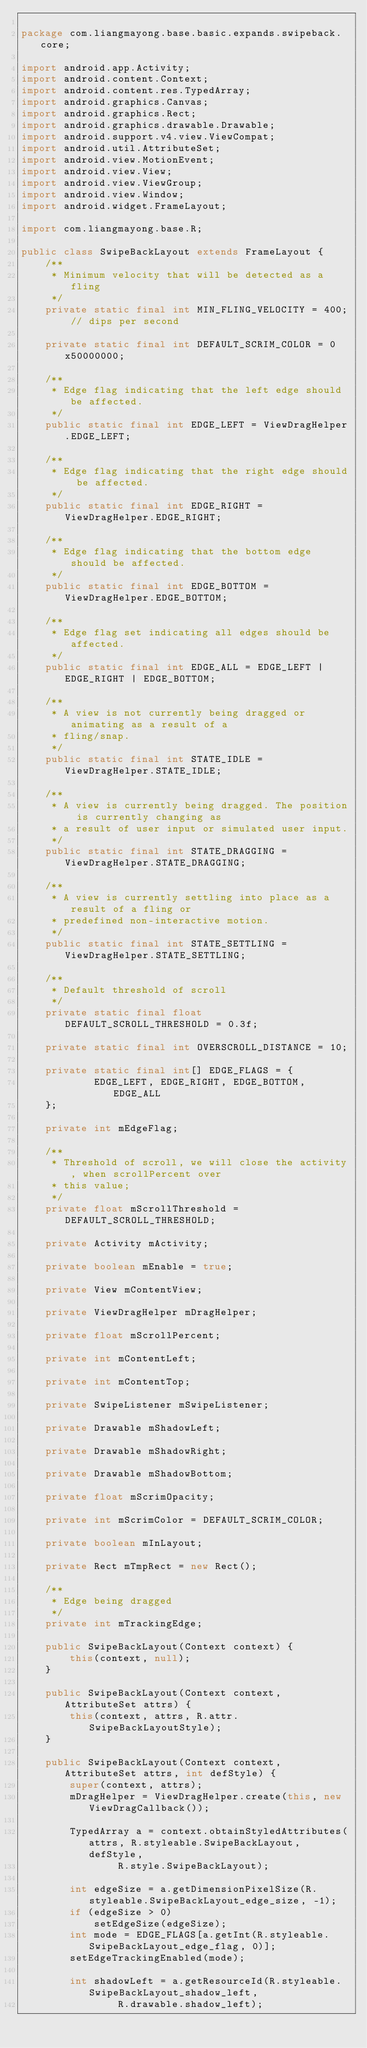<code> <loc_0><loc_0><loc_500><loc_500><_Java_>
package com.liangmayong.base.basic.expands.swipeback.core;

import android.app.Activity;
import android.content.Context;
import android.content.res.TypedArray;
import android.graphics.Canvas;
import android.graphics.Rect;
import android.graphics.drawable.Drawable;
import android.support.v4.view.ViewCompat;
import android.util.AttributeSet;
import android.view.MotionEvent;
import android.view.View;
import android.view.ViewGroup;
import android.view.Window;
import android.widget.FrameLayout;

import com.liangmayong.base.R;

public class SwipeBackLayout extends FrameLayout {
    /**
     * Minimum velocity that will be detected as a fling
     */
    private static final int MIN_FLING_VELOCITY = 400; // dips per second

    private static final int DEFAULT_SCRIM_COLOR = 0x50000000;

    /**
     * Edge flag indicating that the left edge should be affected.
     */
    public static final int EDGE_LEFT = ViewDragHelper.EDGE_LEFT;

    /**
     * Edge flag indicating that the right edge should be affected.
     */
    public static final int EDGE_RIGHT = ViewDragHelper.EDGE_RIGHT;

    /**
     * Edge flag indicating that the bottom edge should be affected.
     */
    public static final int EDGE_BOTTOM = ViewDragHelper.EDGE_BOTTOM;

    /**
     * Edge flag set indicating all edges should be affected.
     */
    public static final int EDGE_ALL = EDGE_LEFT | EDGE_RIGHT | EDGE_BOTTOM;

    /**
     * A view is not currently being dragged or animating as a result of a
     * fling/snap.
     */
    public static final int STATE_IDLE = ViewDragHelper.STATE_IDLE;

    /**
     * A view is currently being dragged. The position is currently changing as
     * a result of user input or simulated user input.
     */
    public static final int STATE_DRAGGING = ViewDragHelper.STATE_DRAGGING;

    /**
     * A view is currently settling into place as a result of a fling or
     * predefined non-interactive motion.
     */
    public static final int STATE_SETTLING = ViewDragHelper.STATE_SETTLING;

    /**
     * Default threshold of scroll
     */
    private static final float DEFAULT_SCROLL_THRESHOLD = 0.3f;

    private static final int OVERSCROLL_DISTANCE = 10;

    private static final int[] EDGE_FLAGS = {
            EDGE_LEFT, EDGE_RIGHT, EDGE_BOTTOM, EDGE_ALL
    };

    private int mEdgeFlag;

    /**
     * Threshold of scroll, we will close the activity, when scrollPercent over
     * this value;
     */
    private float mScrollThreshold = DEFAULT_SCROLL_THRESHOLD;

    private Activity mActivity;

    private boolean mEnable = true;

    private View mContentView;

    private ViewDragHelper mDragHelper;

    private float mScrollPercent;

    private int mContentLeft;

    private int mContentTop;

    private SwipeListener mSwipeListener;

    private Drawable mShadowLeft;

    private Drawable mShadowRight;

    private Drawable mShadowBottom;

    private float mScrimOpacity;

    private int mScrimColor = DEFAULT_SCRIM_COLOR;

    private boolean mInLayout;

    private Rect mTmpRect = new Rect();

    /**
     * Edge being dragged
     */
    private int mTrackingEdge;

    public SwipeBackLayout(Context context) {
        this(context, null);
    }

    public SwipeBackLayout(Context context, AttributeSet attrs) {
        this(context, attrs, R.attr.SwipeBackLayoutStyle);
    }

    public SwipeBackLayout(Context context, AttributeSet attrs, int defStyle) {
        super(context, attrs);
        mDragHelper = ViewDragHelper.create(this, new ViewDragCallback());

        TypedArray a = context.obtainStyledAttributes(attrs, R.styleable.SwipeBackLayout, defStyle,
                R.style.SwipeBackLayout);

        int edgeSize = a.getDimensionPixelSize(R.styleable.SwipeBackLayout_edge_size, -1);
        if (edgeSize > 0)
            setEdgeSize(edgeSize);
        int mode = EDGE_FLAGS[a.getInt(R.styleable.SwipeBackLayout_edge_flag, 0)];
        setEdgeTrackingEnabled(mode);

        int shadowLeft = a.getResourceId(R.styleable.SwipeBackLayout_shadow_left,
                R.drawable.shadow_left);</code> 